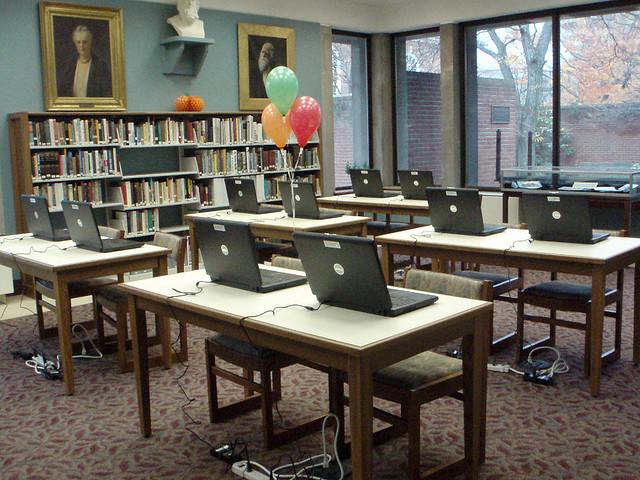How can you tell someone probably has their birthday today?
Concise answer only. Balloons. Might this be a vacation home?
Quick response, please. No. How many people can sit at the same table?
Be succinct. 2. Is this a classroom?
Answer briefly. Yes. What is this room for?
Be succinct. Learning. What are on the table?
Answer briefly. Laptops. How many laptops are there?
Short answer required. 10. How many windows are there?
Concise answer only. 4. Are all of the seats in the picture facing the same direction?
Quick response, please. Yes. Is this a restaurant?
Short answer required. No. 